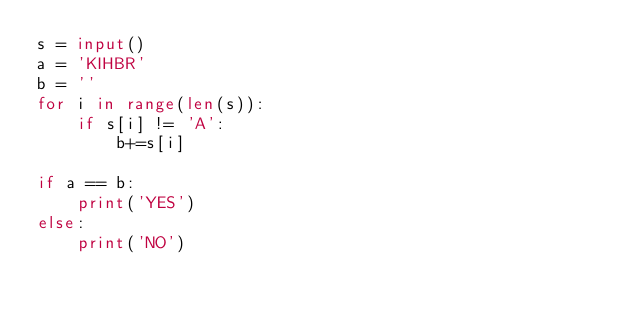<code> <loc_0><loc_0><loc_500><loc_500><_Python_>s = input()
a = 'KIHBR'
b = ''
for i in range(len(s)):
    if s[i] != 'A':
        b+=s[i]

if a == b:
    print('YES')
else:
    print('NO')</code> 